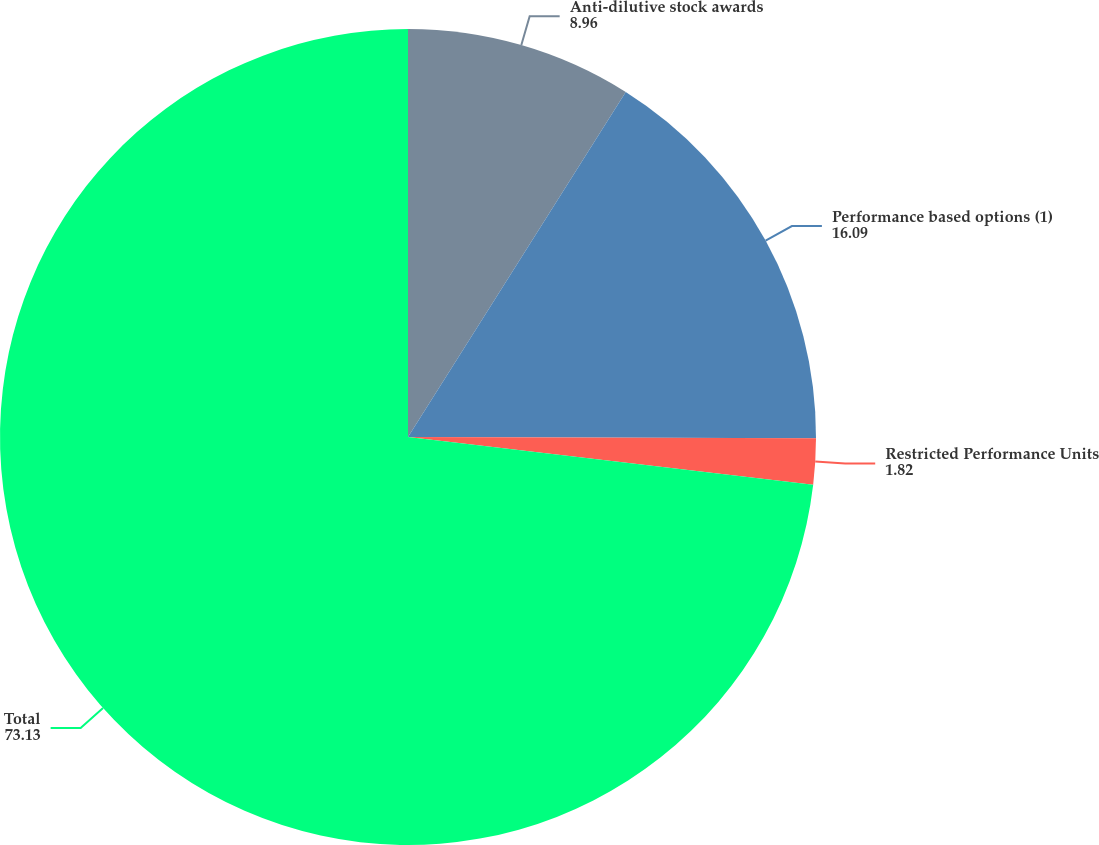<chart> <loc_0><loc_0><loc_500><loc_500><pie_chart><fcel>Anti-dilutive stock awards<fcel>Performance based options (1)<fcel>Restricted Performance Units<fcel>Total<nl><fcel>8.96%<fcel>16.09%<fcel>1.82%<fcel>73.13%<nl></chart> 